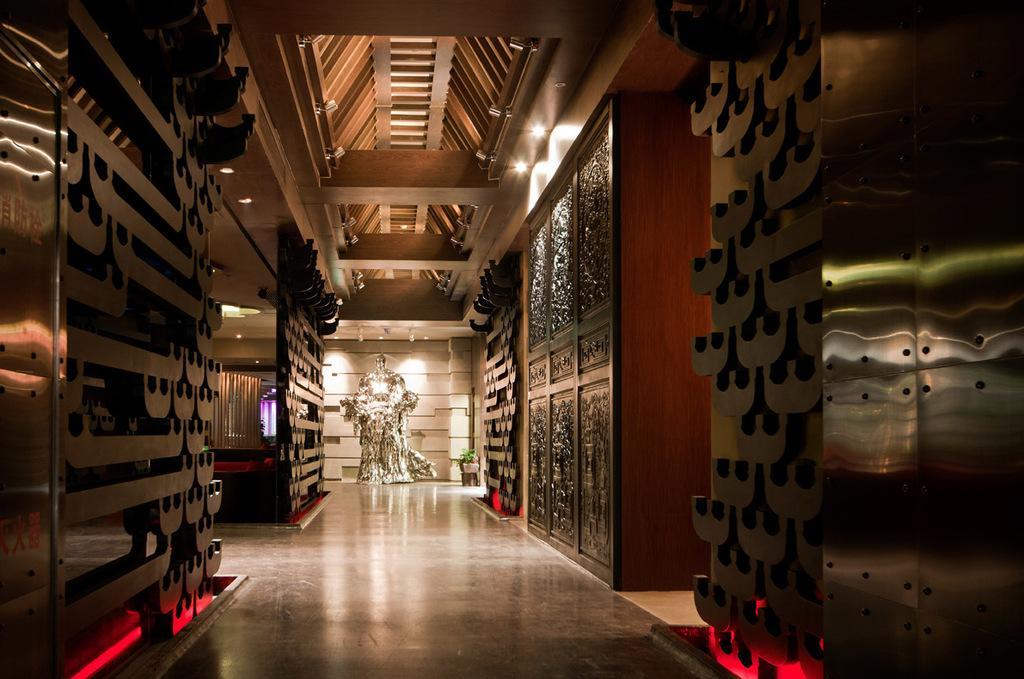Can you describe this image briefly? In this image, I can see a wall, doors, lights on a rooftop, house plant and some objects on the floor. This picture might be taken in a building. 